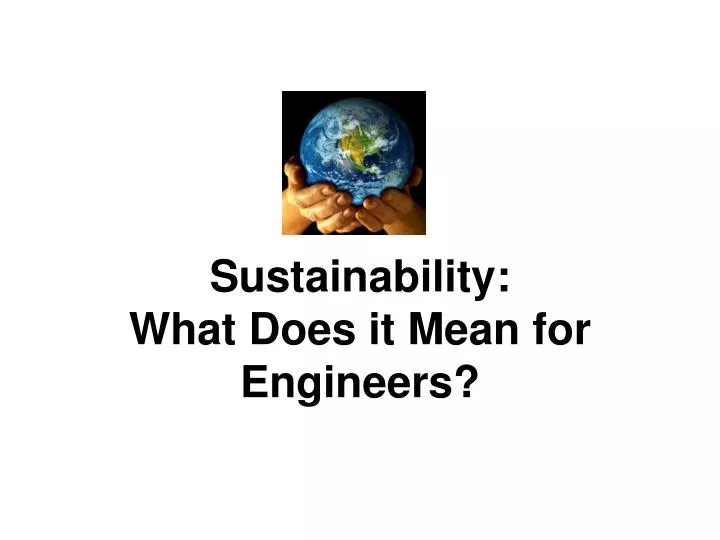What might be an unexpected challenge that engineers could face when incorporating sustainability into their projects? One unexpected challenge might be balancing economic feasibility with sustainable practices. Sustainable materials and technologies can sometimes have higher upfront costs. Engineers must find innovative ways to justify these costs by demonstrating long-term savings and benefits. Additionally, there may be resistance from stakeholders who are more focused on immediate profits rather than long-term environmental impact. How can engineers overcome these challenges creatively? Engineers can overcome these challenges by leveraging a few strategies:
1. **Lifecycle Cost Analysis**: Highlighting the long-term financial benefits of sustainable practices by showing reduced operational costs, maintenance, and energy savings over time.
2. **Public-Private Partnerships**: Collaborating with governments and private sectors to share the initial investment burden, making projects more financially viable.
3. **Innovative Financing Models**: Exploring financing options like green bonds or sustainability-linked loans that offer favorable terms for eco-friendly projects.
4. **Education and Advocacy**: Educating stakeholders about the environmental, social, and economic benefits of sustainability, thus gaining their buy-in and support. Imagine if engineers designed a city entirely based on the concept of sustainability described in the image. What unique features would this city have? In a city designed with sustainability at its core, you would find several distinctive features:
1. **Green Buildings**: Structures with solar panels, green roofs, and efficient insulation to minimize energy use.
2. **Integrated Public Transport**: Efficient, electrified public transport networks, reducing reliance on personal vehicles.
3. **Renewable Energy Grid**: A city-wide grid powered by a mix of solar, wind, and possibly even tidal energy sources.
4. **Urban Farms and Green Spaces**: Extensive urban farming initiatives and parks to promote local food production and enhance biodiversity.
5. **Smart Water Management Systems**: Advanced systems for water recycling, rainwater harvesting, and greywater use.
6. **Circular Waste Management**: Facilities designed to recycle and repurpose all waste, aiming for zero waste to landfills.
7. **Eco-Friendly Transportation**: Infrastructure supporting electric vehicles, bike-sharing programs, and pedestrian-friendly pathways. 